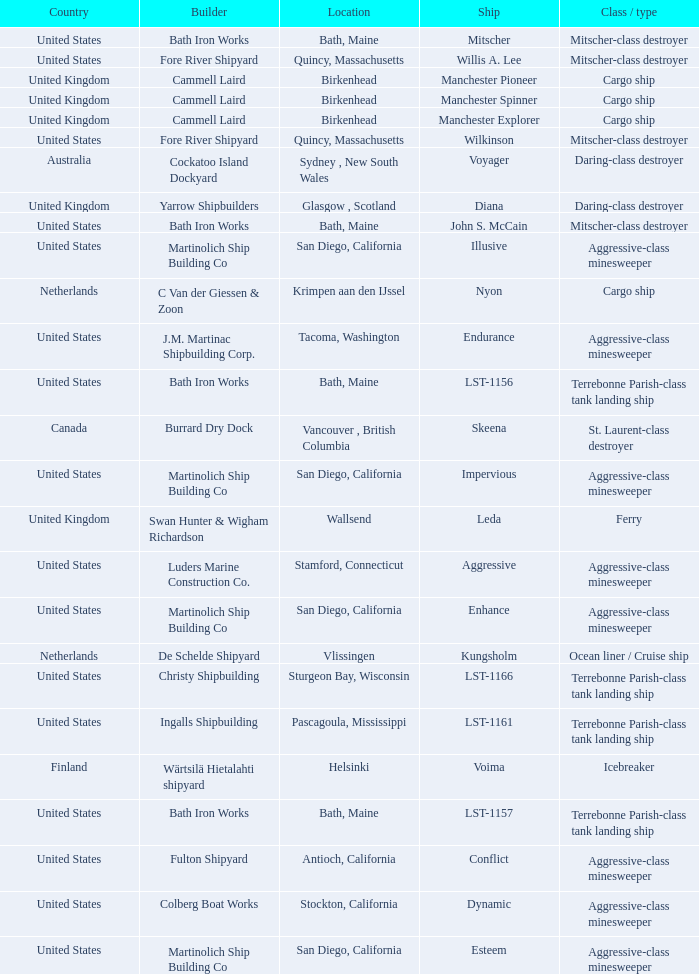What Ship was Built by Cammell Laird? Manchester Pioneer, Manchester Spinner, Manchester Explorer. I'm looking to parse the entire table for insights. Could you assist me with that? {'header': ['Country', 'Builder', 'Location', 'Ship', 'Class / type'], 'rows': [['United States', 'Bath Iron Works', 'Bath, Maine', 'Mitscher', 'Mitscher-class destroyer'], ['United States', 'Fore River Shipyard', 'Quincy, Massachusetts', 'Willis A. Lee', 'Mitscher-class destroyer'], ['United Kingdom', 'Cammell Laird', 'Birkenhead', 'Manchester Pioneer', 'Cargo ship'], ['United Kingdom', 'Cammell Laird', 'Birkenhead', 'Manchester Spinner', 'Cargo ship'], ['United Kingdom', 'Cammell Laird', 'Birkenhead', 'Manchester Explorer', 'Cargo ship'], ['United States', 'Fore River Shipyard', 'Quincy, Massachusetts', 'Wilkinson', 'Mitscher-class destroyer'], ['Australia', 'Cockatoo Island Dockyard', 'Sydney , New South Wales', 'Voyager', 'Daring-class destroyer'], ['United Kingdom', 'Yarrow Shipbuilders', 'Glasgow , Scotland', 'Diana', 'Daring-class destroyer'], ['United States', 'Bath Iron Works', 'Bath, Maine', 'John S. McCain', 'Mitscher-class destroyer'], ['United States', 'Martinolich Ship Building Co', 'San Diego, California', 'Illusive', 'Aggressive-class minesweeper'], ['Netherlands', 'C Van der Giessen & Zoon', 'Krimpen aan den IJssel', 'Nyon', 'Cargo ship'], ['United States', 'J.M. Martinac Shipbuilding Corp.', 'Tacoma, Washington', 'Endurance', 'Aggressive-class minesweeper'], ['United States', 'Bath Iron Works', 'Bath, Maine', 'LST-1156', 'Terrebonne Parish-class tank landing ship'], ['Canada', 'Burrard Dry Dock', 'Vancouver , British Columbia', 'Skeena', 'St. Laurent-class destroyer'], ['United States', 'Martinolich Ship Building Co', 'San Diego, California', 'Impervious', 'Aggressive-class minesweeper'], ['United Kingdom', 'Swan Hunter & Wigham Richardson', 'Wallsend', 'Leda', 'Ferry'], ['United States', 'Luders Marine Construction Co.', 'Stamford, Connecticut', 'Aggressive', 'Aggressive-class minesweeper'], ['United States', 'Martinolich Ship Building Co', 'San Diego, California', 'Enhance', 'Aggressive-class minesweeper'], ['Netherlands', 'De Schelde Shipyard', 'Vlissingen', 'Kungsholm', 'Ocean liner / Cruise ship'], ['United States', 'Christy Shipbuilding', 'Sturgeon Bay, Wisconsin', 'LST-1166', 'Terrebonne Parish-class tank landing ship'], ['United States', 'Ingalls Shipbuilding', 'Pascagoula, Mississippi', 'LST-1161', 'Terrebonne Parish-class tank landing ship'], ['Finland', 'Wärtsilä Hietalahti shipyard', 'Helsinki', 'Voima', 'Icebreaker'], ['United States', 'Bath Iron Works', 'Bath, Maine', 'LST-1157', 'Terrebonne Parish-class tank landing ship'], ['United States', 'Fulton Shipyard', 'Antioch, California', 'Conflict', 'Aggressive-class minesweeper'], ['United States', 'Colberg Boat Works', 'Stockton, California', 'Dynamic', 'Aggressive-class minesweeper'], ['United States', 'Martinolich Ship Building Co', 'San Diego, California', 'Esteem', 'Aggressive-class minesweeper']]} 